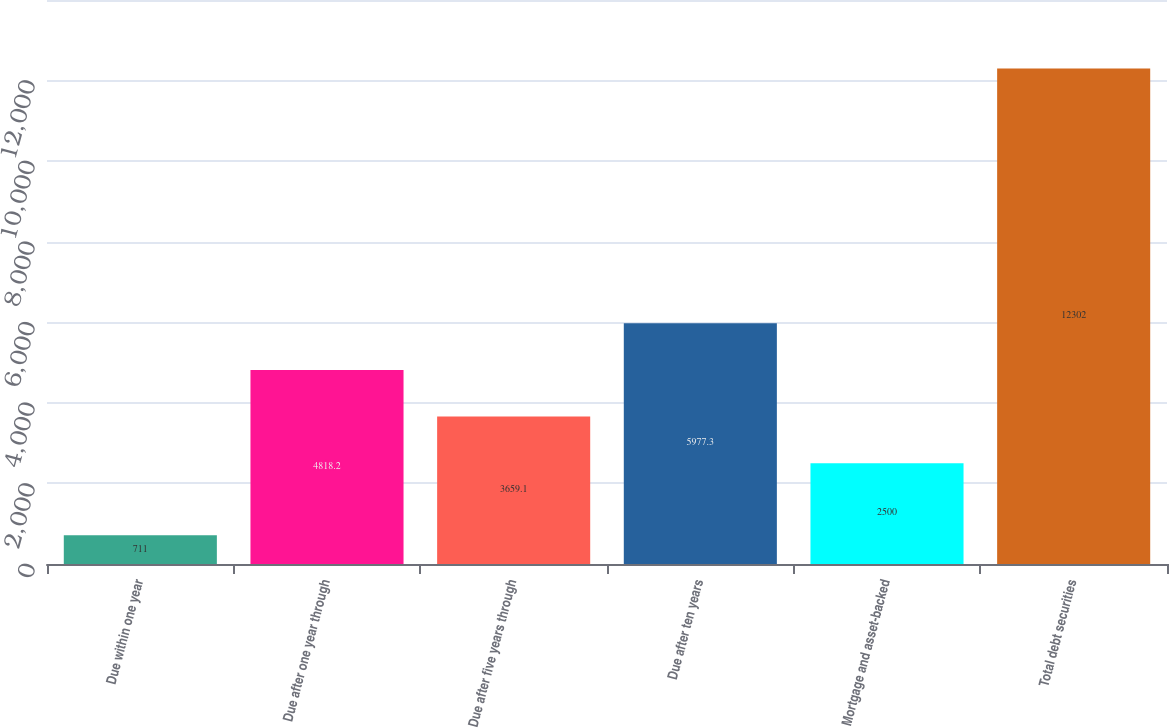Convert chart to OTSL. <chart><loc_0><loc_0><loc_500><loc_500><bar_chart><fcel>Due within one year<fcel>Due after one year through<fcel>Due after five years through<fcel>Due after ten years<fcel>Mortgage and asset-backed<fcel>Total debt securities<nl><fcel>711<fcel>4818.2<fcel>3659.1<fcel>5977.3<fcel>2500<fcel>12302<nl></chart> 